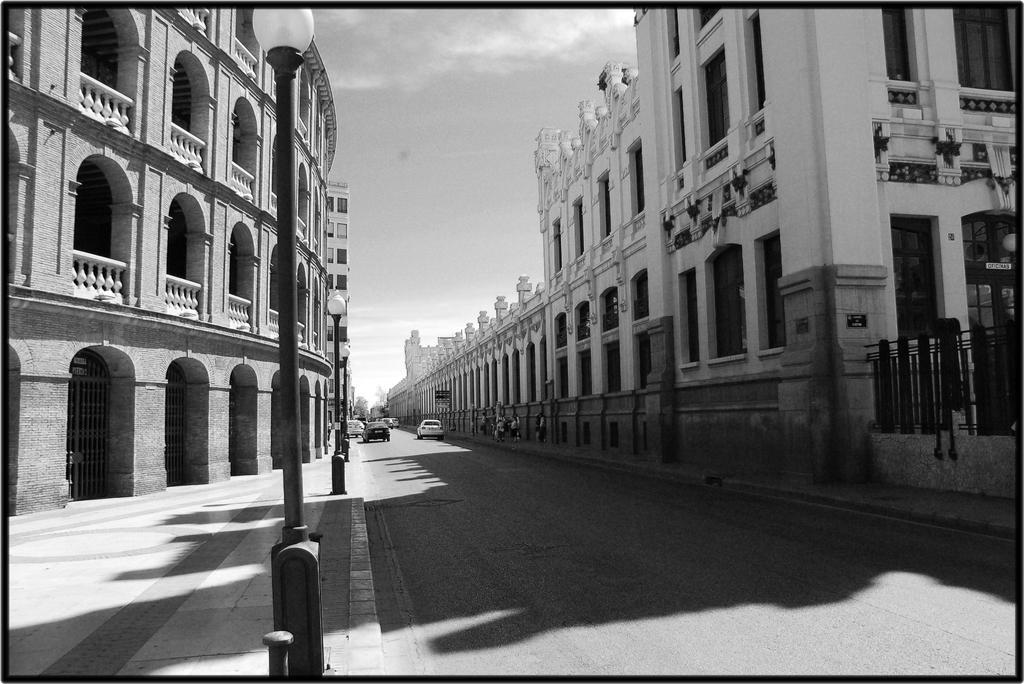Please provide a concise description of this image. In this picture I can see buildings, street lights and vehicles on the road. In the background I can see the sky. This picture is black and white in color. 